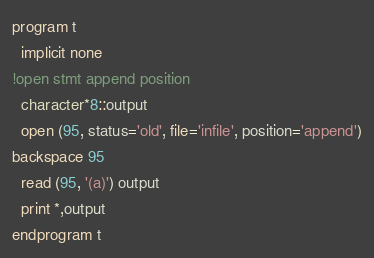<code> <loc_0><loc_0><loc_500><loc_500><_FORTRAN_>program t
  implicit none
!open stmt append position 
  character*8::output
  open (95, status='old', file='infile', position='append')
backspace 95
  read (95, '(a)') output
  print *,output
endprogram t
</code> 